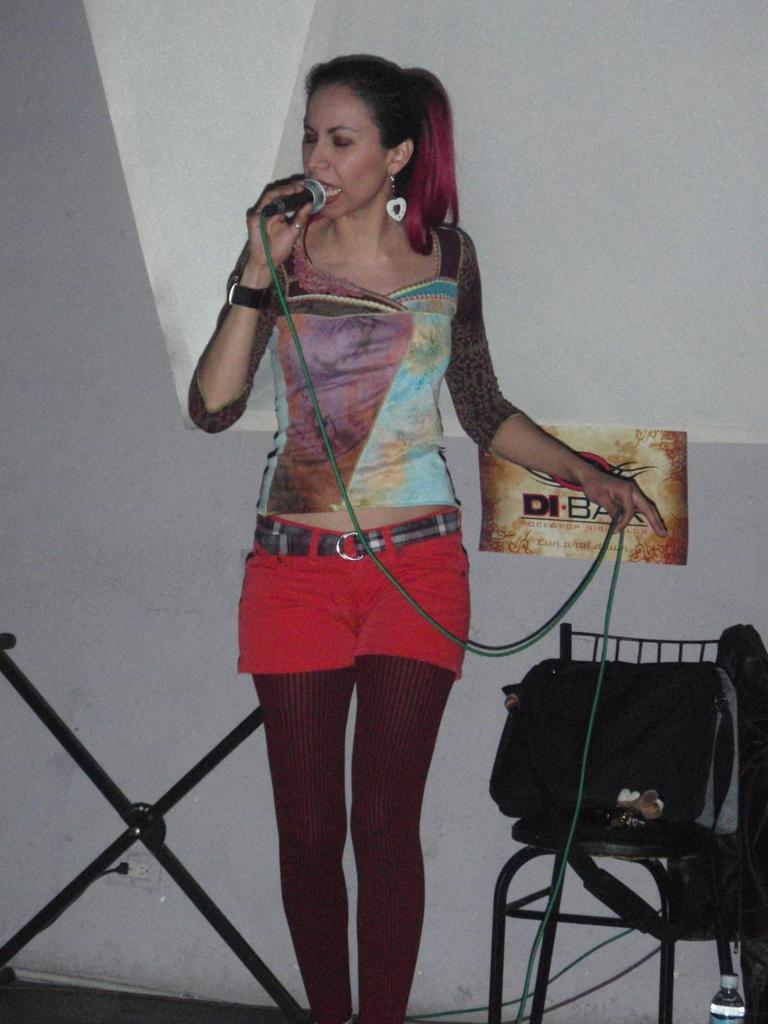What is the main subject of the image? There is a woman standing in the center of the image. What is the woman holding in the image? The woman is holding a mic with a wire. Can you describe any other objects in the image? There is a bottle visible in the image, a bag on a chair, a stand, and a paper pasted on a wall. What type of noise is the representative making in the image? There is no representative present in the image, and therefore no noise can be attributed to them. 